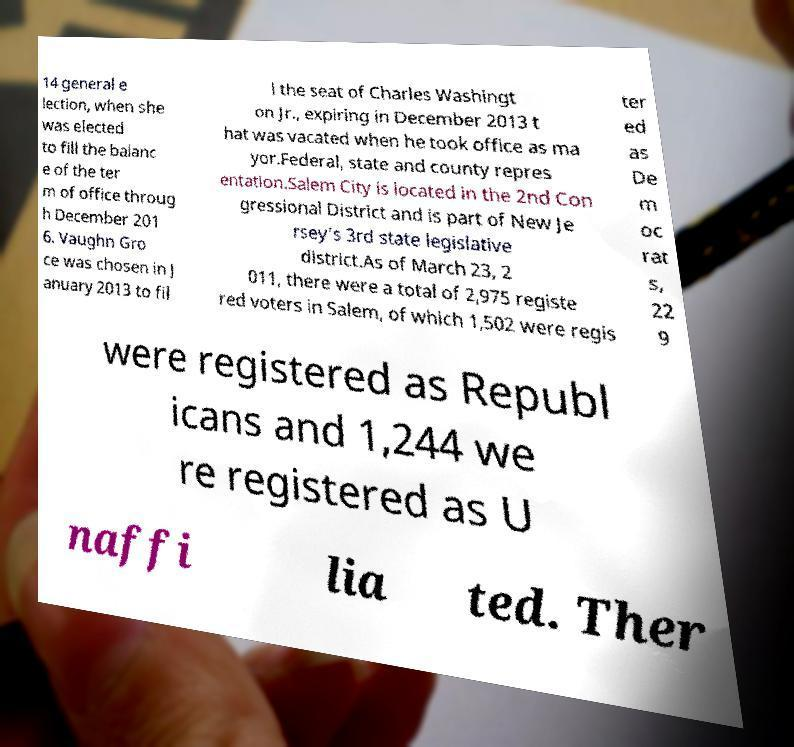What messages or text are displayed in this image? I need them in a readable, typed format. 14 general e lection, when she was elected to fill the balanc e of the ter m of office throug h December 201 6. Vaughn Gro ce was chosen in J anuary 2013 to fil l the seat of Charles Washingt on Jr., expiring in December 2013 t hat was vacated when he took office as ma yor.Federal, state and county repres entation.Salem City is located in the 2nd Con gressional District and is part of New Je rsey's 3rd state legislative district.As of March 23, 2 011, there were a total of 2,975 registe red voters in Salem, of which 1,502 were regis ter ed as De m oc rat s, 22 9 were registered as Republ icans and 1,244 we re registered as U naffi lia ted. Ther 